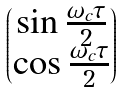Convert formula to latex. <formula><loc_0><loc_0><loc_500><loc_500>\begin{pmatrix} \sin \frac { \omega _ { c } \tau } { 2 } \\ \cos \frac { \omega _ { c } \tau } { 2 } \end{pmatrix}</formula> 